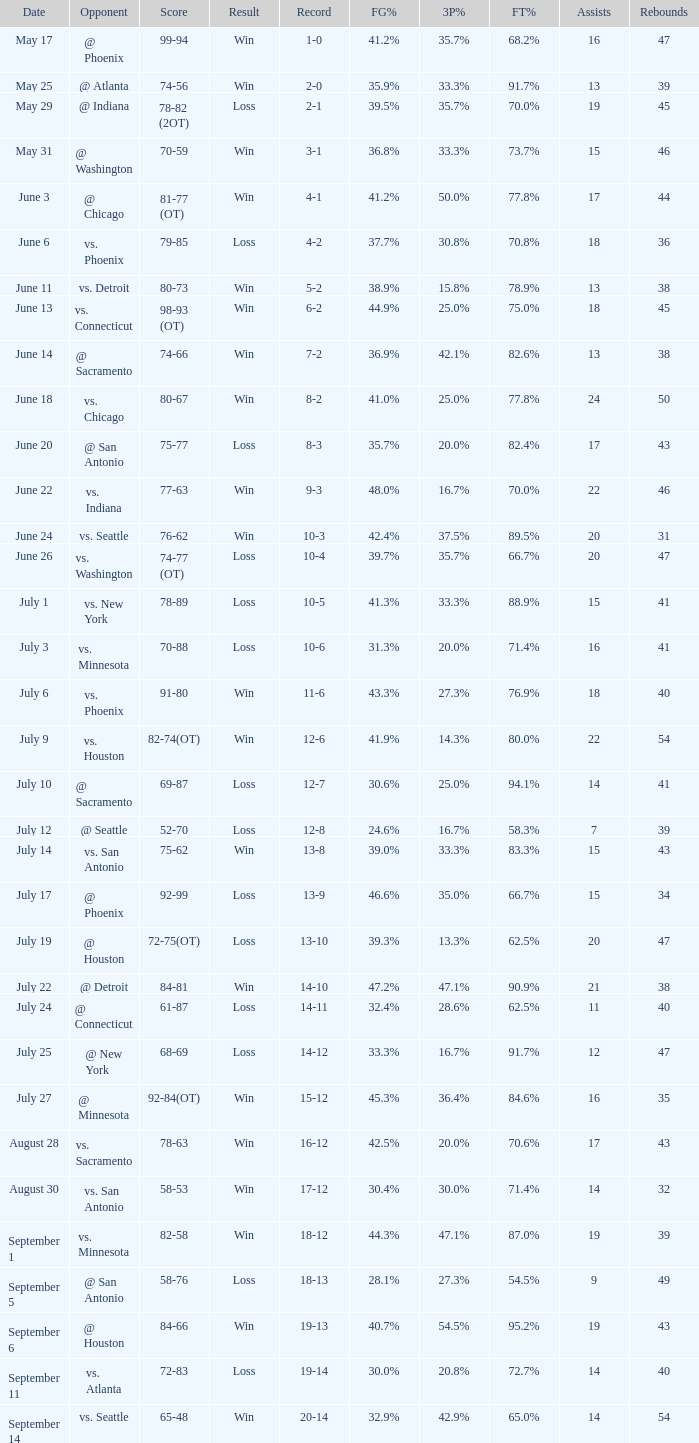What is the Record of the game on September 6? 19-13. 